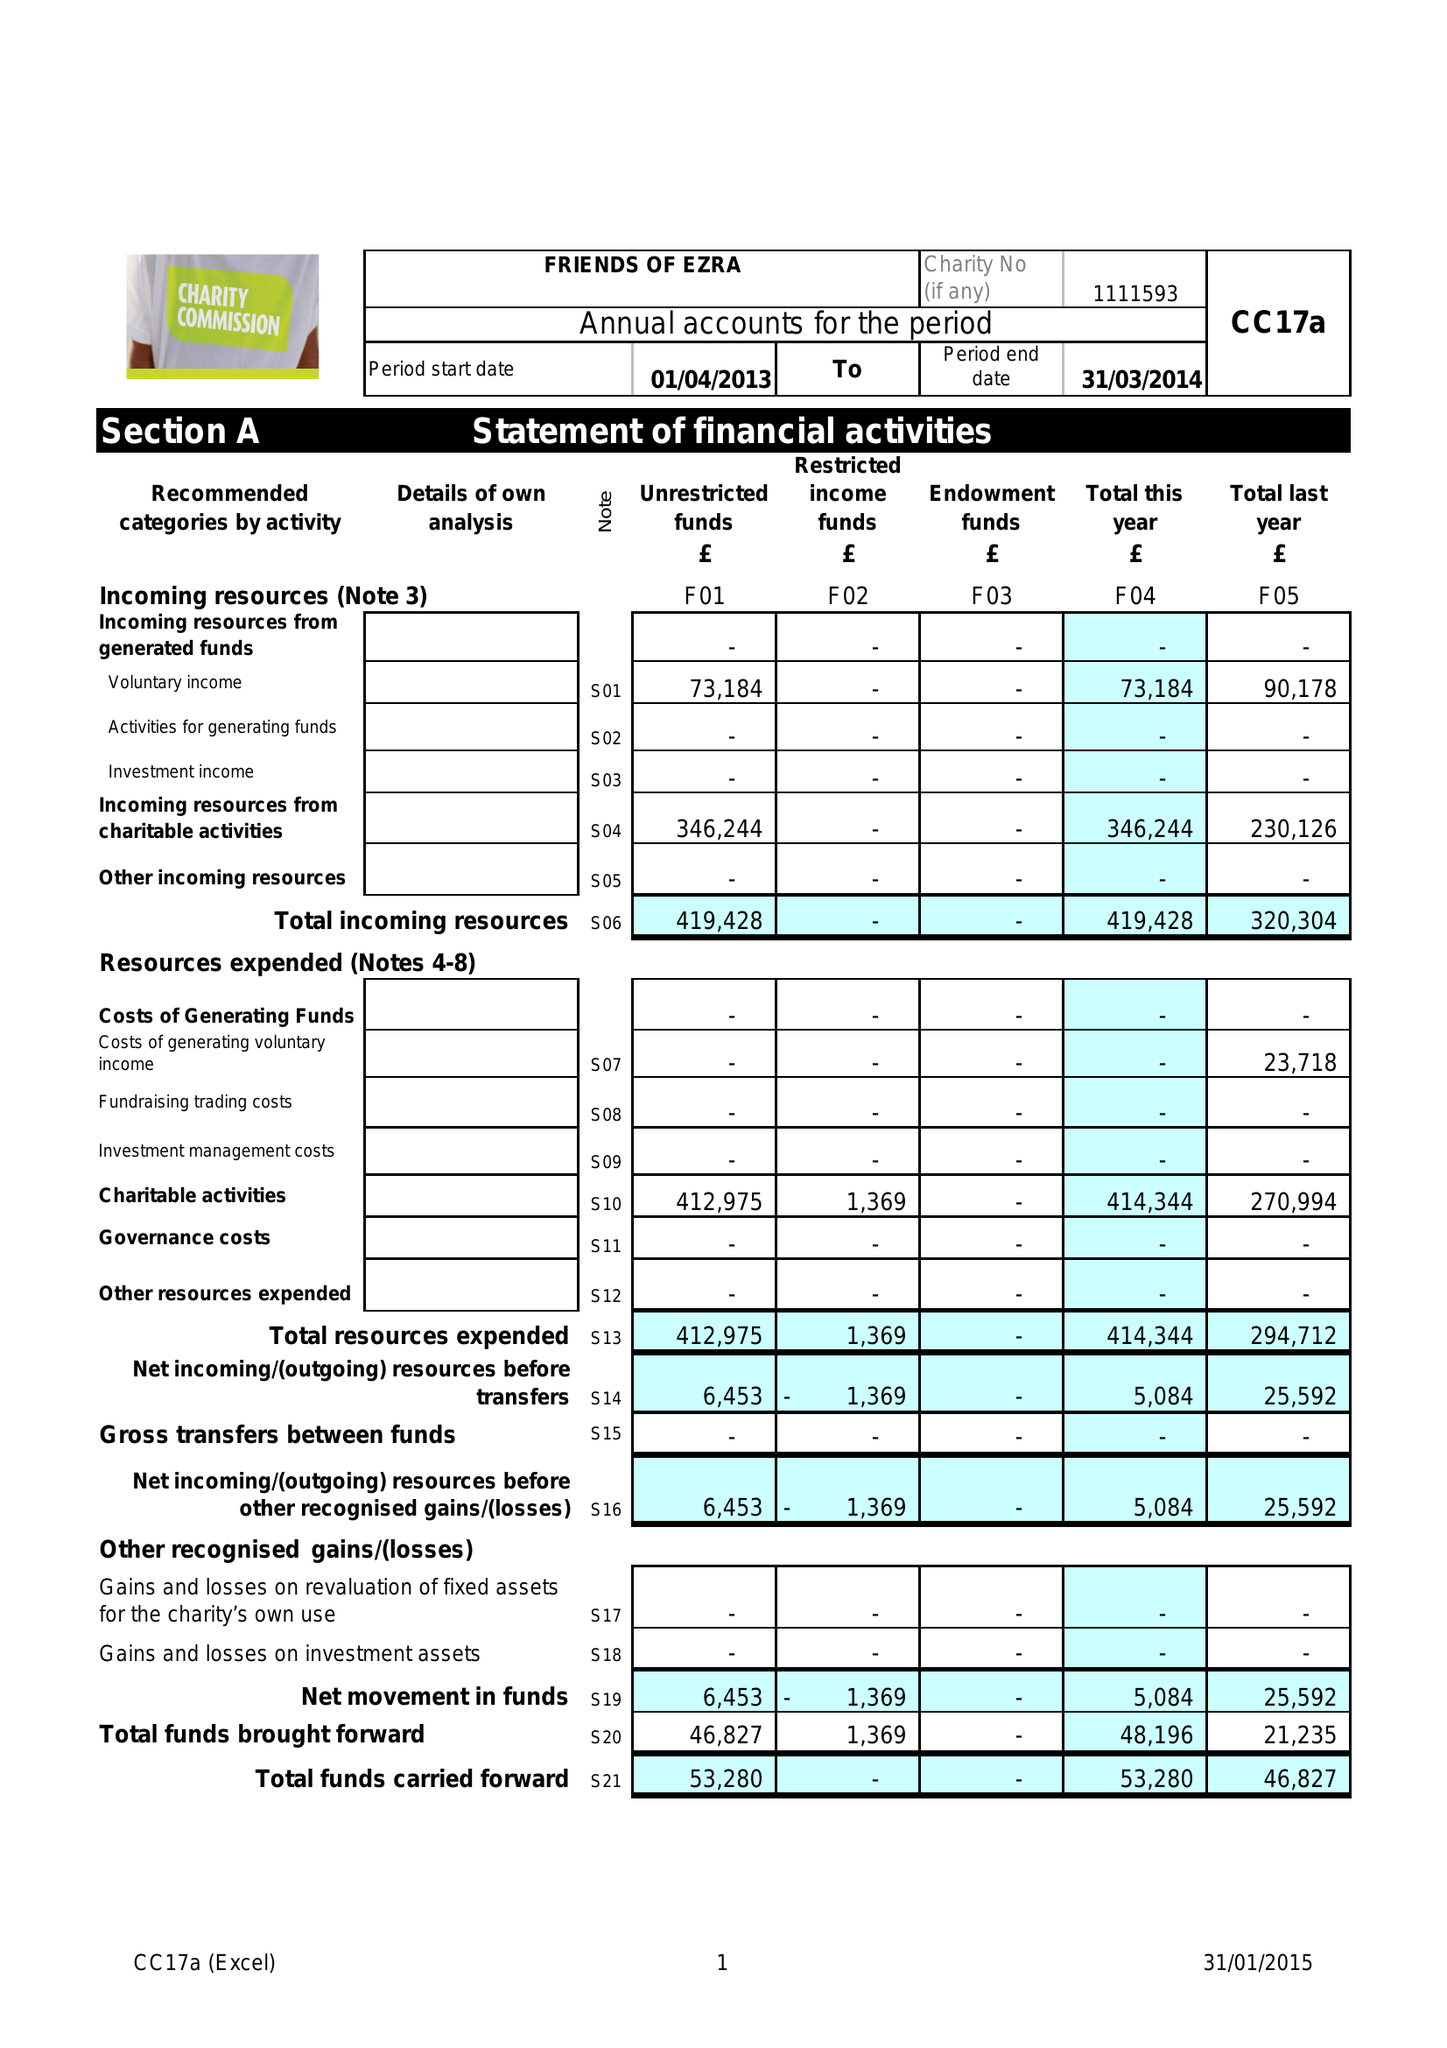What is the value for the income_annually_in_british_pounds?
Answer the question using a single word or phrase. 419428.00 